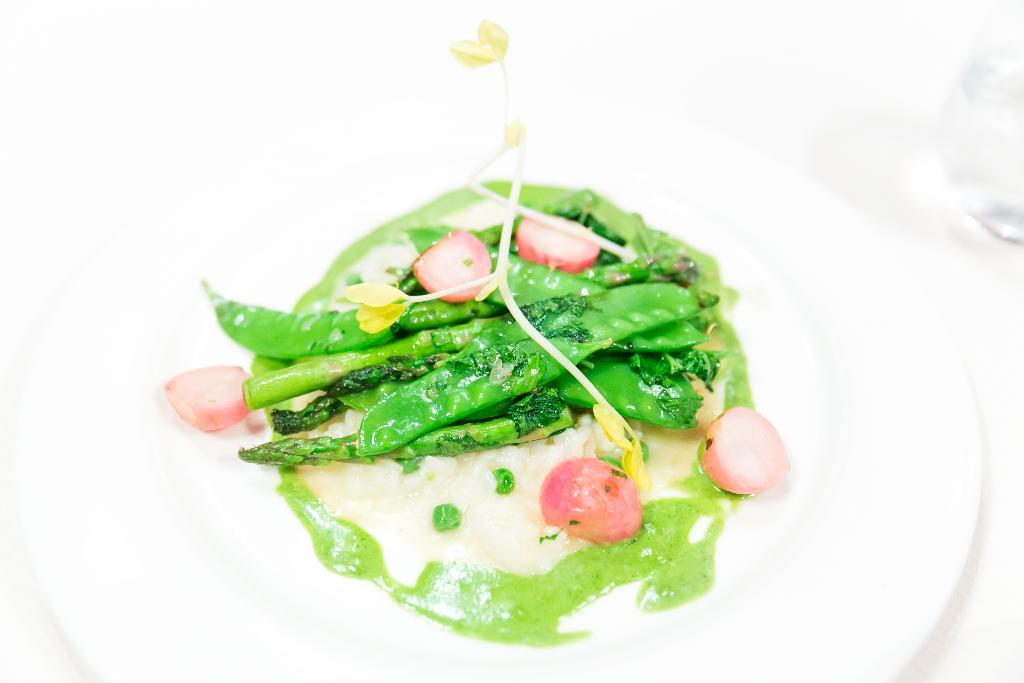What is on the plate in the image? There is food in a plate in the image. What can be seen on the right side of the image? There is a glass on the right side of the image. What color is the background of the image? The background of the image is white. How many women are participating in the test in the image? There are no women or tests present in the image. What type of selection process is depicted in the image? There is no selection process depicted in the image; it features a plate of food and a glass. 